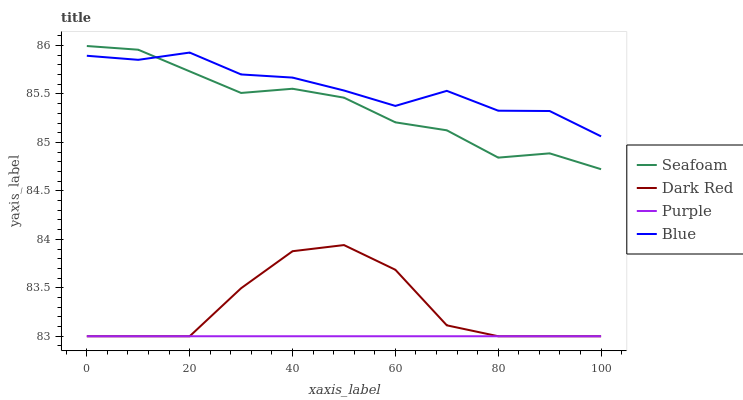Does Purple have the minimum area under the curve?
Answer yes or no. Yes. Does Blue have the maximum area under the curve?
Answer yes or no. Yes. Does Dark Red have the minimum area under the curve?
Answer yes or no. No. Does Dark Red have the maximum area under the curve?
Answer yes or no. No. Is Purple the smoothest?
Answer yes or no. Yes. Is Dark Red the roughest?
Answer yes or no. Yes. Is Seafoam the smoothest?
Answer yes or no. No. Is Seafoam the roughest?
Answer yes or no. No. Does Seafoam have the lowest value?
Answer yes or no. No. Does Seafoam have the highest value?
Answer yes or no. Yes. Does Dark Red have the highest value?
Answer yes or no. No. Is Dark Red less than Seafoam?
Answer yes or no. Yes. Is Blue greater than Purple?
Answer yes or no. Yes. Does Dark Red intersect Purple?
Answer yes or no. Yes. Is Dark Red less than Purple?
Answer yes or no. No. Is Dark Red greater than Purple?
Answer yes or no. No. Does Dark Red intersect Seafoam?
Answer yes or no. No. 